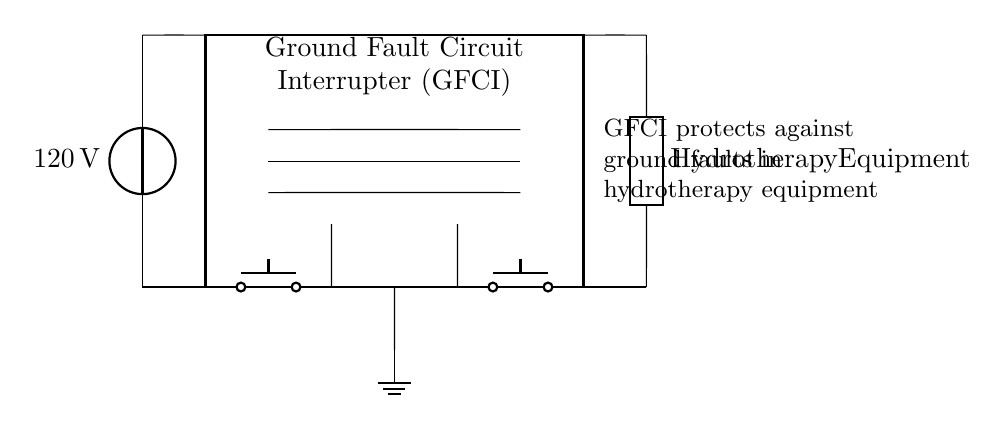What is the voltage of this circuit? The voltage is 120 volts, which is indicated next to the voltage source in the circuit diagram.
Answer: 120 volts What type of device is the GFCI protecting? The GFCI is providing protection for hydrotherapy equipment, which is specified in the label next to the load in the circuit diagram.
Answer: Hydrotherapy equipment How many push buttons are present in the circuit? There are two push buttons present, as shown by the two distinct button symbols in the circuit diagram.
Answer: Two What is the role of the sense coil in the GFCI? The sense coil monitors the current to detect any imbalances, indicating potential ground faults, and is located within the GFCI box in the diagram.
Answer: Detects imbalances What is the function of the ground connection in this diagram? The ground connection provides a safety path for electrical faults, preventing electrical shock. It is denoted by the ground symbol at the bottom of the circuit.
Answer: Safety path Why is a GFCI necessary for hydrotherapy equipment? A GFCI is necessary because hydrotherapy equipment operates with water, which increases the risk of electrical shock; the GFCI mitigates this risk by quickly cutting off power during faults.
Answer: Reduces electrical shock risk 